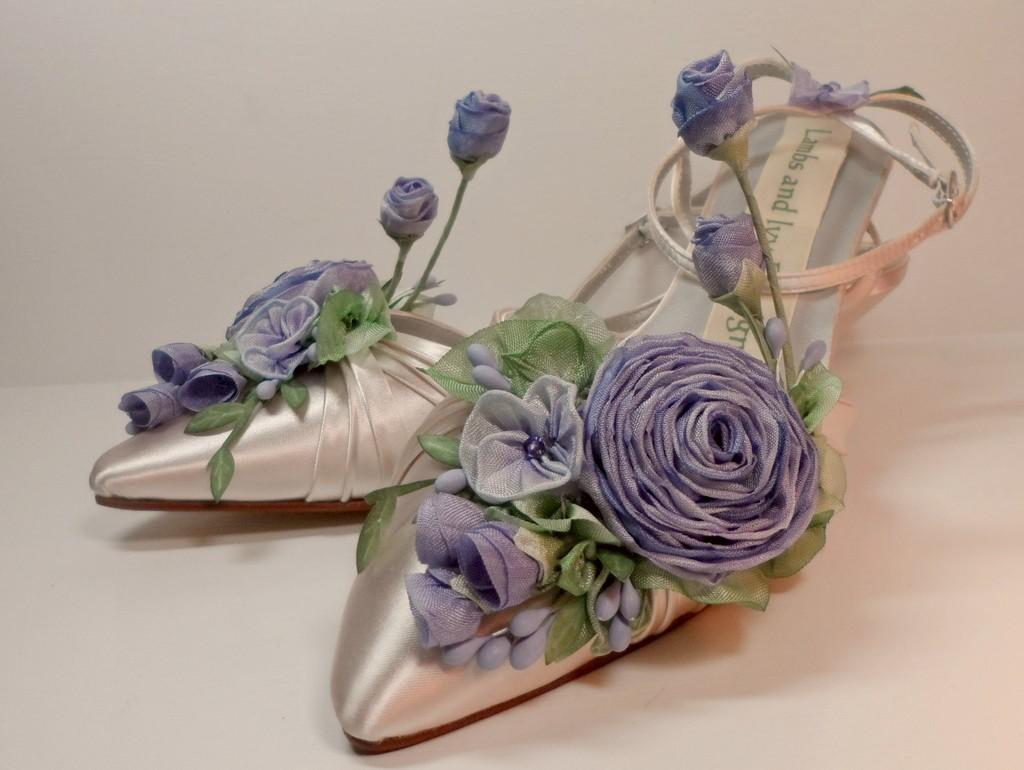What type of footwear is on the floor in the image? There are sandals present on the floor. Can you describe the design of the sandals? The sandals have a floral design. What type of marble is used to create the son's knowledge in the image? There is no marble, son, or knowledge present in the image; it only features sandals with a floral design on the floor. 